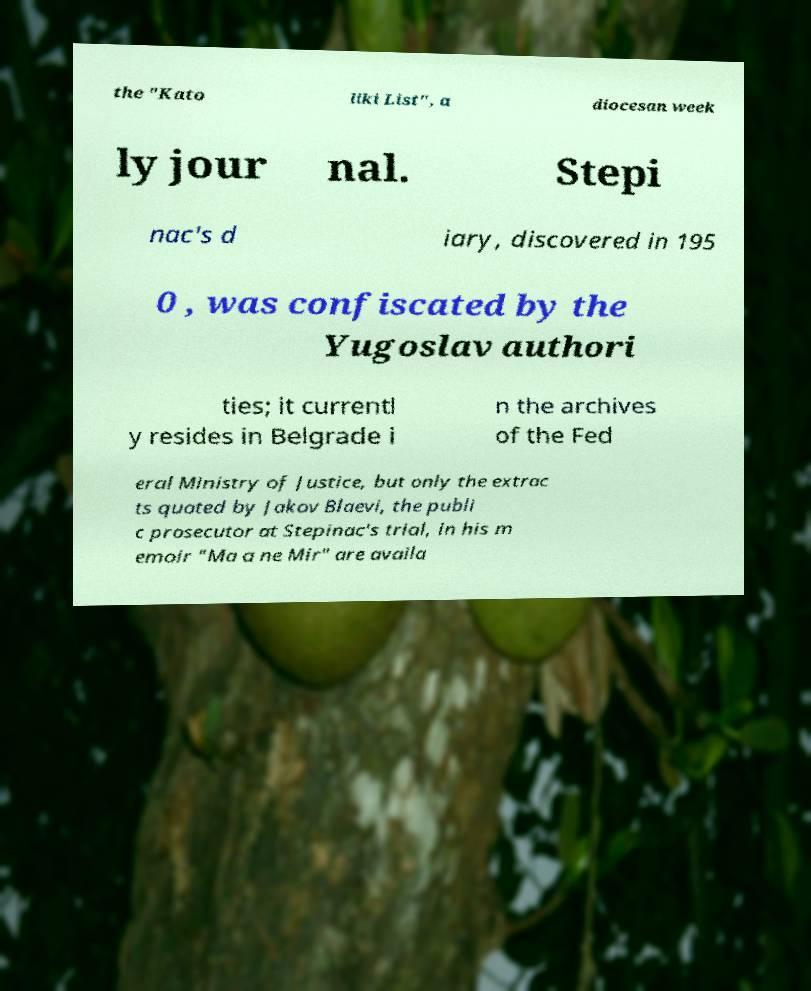Can you accurately transcribe the text from the provided image for me? the "Kato liki List", a diocesan week ly jour nal. Stepi nac's d iary, discovered in 195 0 , was confiscated by the Yugoslav authori ties; it currentl y resides in Belgrade i n the archives of the Fed eral Ministry of Justice, but only the extrac ts quoted by Jakov Blaevi, the publi c prosecutor at Stepinac's trial, in his m emoir "Ma a ne Mir" are availa 